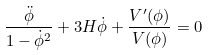<formula> <loc_0><loc_0><loc_500><loc_500>\frac { \ddot { \phi } } { 1 - \dot { \phi } ^ { 2 } } + 3 H \dot { \phi } + \frac { V ^ { \prime } ( \phi ) } { V ( \phi ) } = 0</formula> 